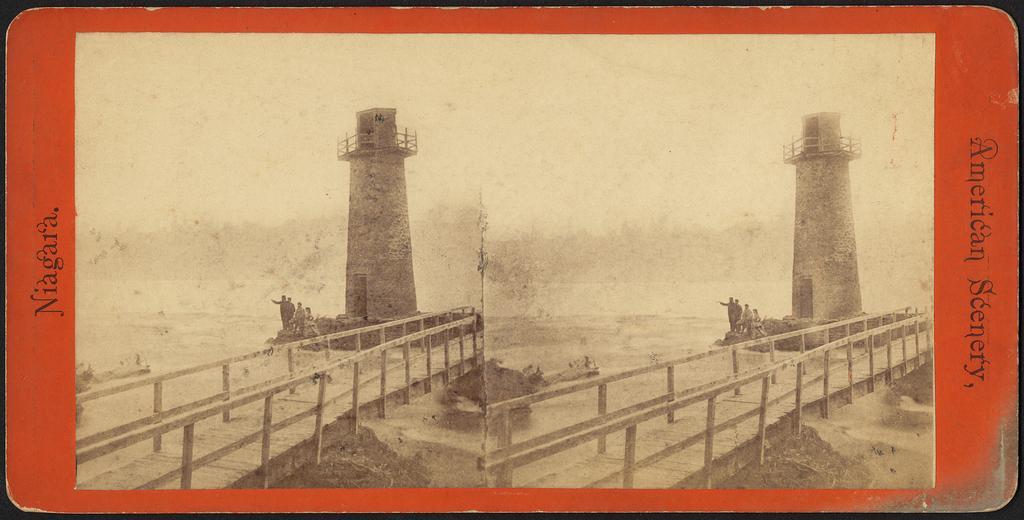Could you give a brief overview of what you see in this image? This is an edited image, there are two image they both are same, there is light house and a bridge four persons are standing near the light house, in the second image there is a light house four persons are standing near the lighthouse, in the background there is sea. 